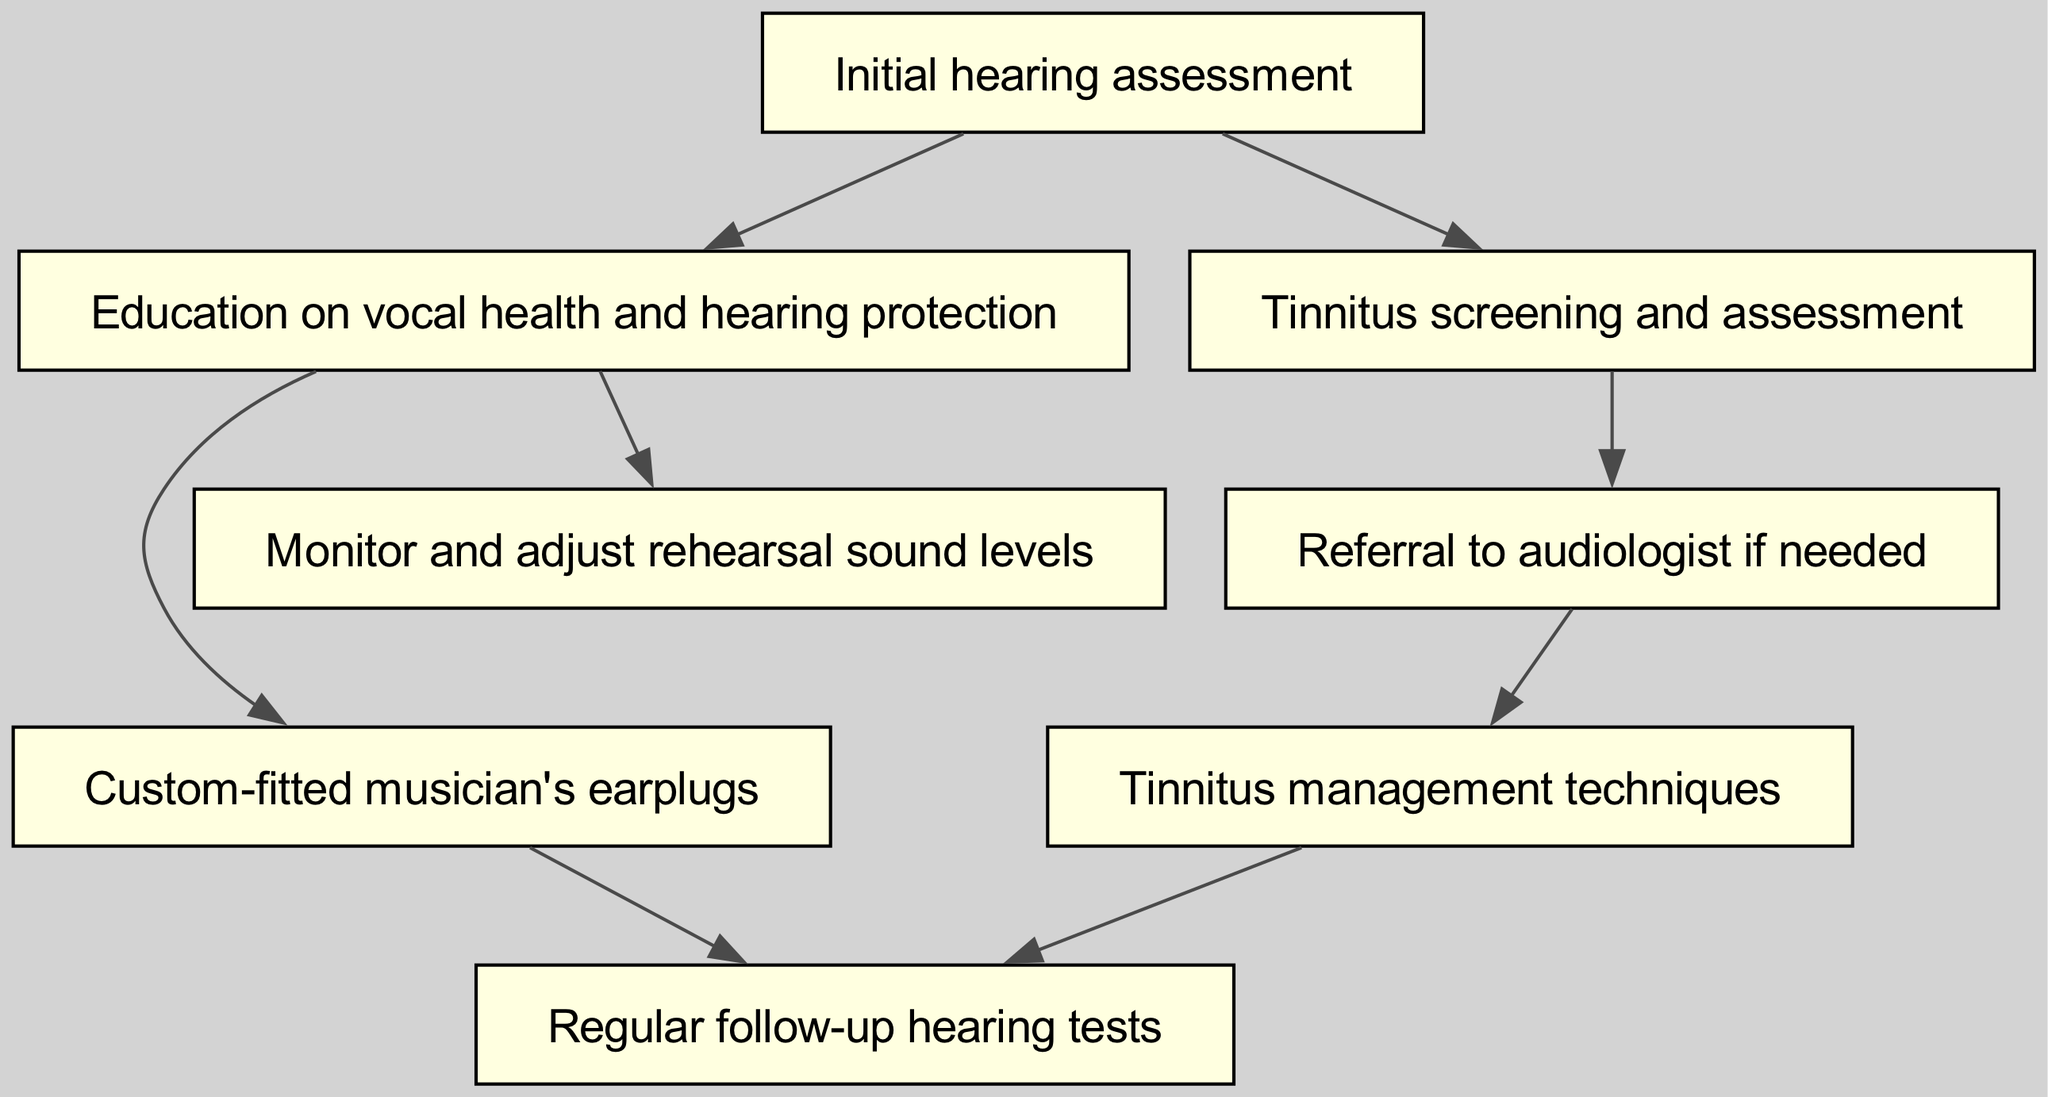What is the first step in the pathway? The first step in the pathway as per the diagram is the "Initial hearing assessment" node. This is the starting point of the clinical pathway.
Answer: Initial hearing assessment How many nodes are present in the diagram? To find the number of nodes, we can count the entries under the "nodes" section of the data. There are 8 nodes listed.
Answer: 8 What follows after "Education on vocal health and hearing protection"? From the diagram, the next steps after "Education on vocal health and hearing protection" are "Custom-fitted musician's earplugs" and "Monitor and adjust rehearsal sound levels." Both actions can occur based on the education received.
Answer: Custom-fitted musician's earplugs, Monitor and adjust rehearsal sound levels Which node indicates the need for audiologist referral? The "Tinnitus screening and assessment" node leads to a "Referral to audiologist if needed." This indicates that a referral is contingent upon the results of the tinnitus screening.
Answer: Referral to audiologist if needed What is the final node that connects to "Regular follow-up hearing tests"? There are two nodes that lead to "Regular follow-up hearing tests": "Custom-fitted musician's earplugs" and "Tinnitus management techniques." This means that after these interventions, regular follow-up is necessary.
Answer: Custom-fitted musician's earplugs, Tinnitus management techniques What is the relationship between "Initial hearing assessment" and "Tinnitus screening and assessment"? The diagram shows a direct edge from "Initial hearing assessment" to "Tinnitus screening and assessment," indicating that tinnitus screening can occur directly after the initial assessment.
Answer: Direct relationship How does tinnitus screening affect further actions in the pathway? Following "Tinnitus screening and assessment," it leads to a "Referral to audiologist if needed." Thus, the results of the tinnitus screening determine whether referral is necessary.
Answer: Determines referral necessity Which technique is listed for managing tinnitus? The node labeled "Tinnitus management techniques" directly addresses the strategies available for managing tinnitus based on prior assessments.
Answer: Tinnitus management techniques 